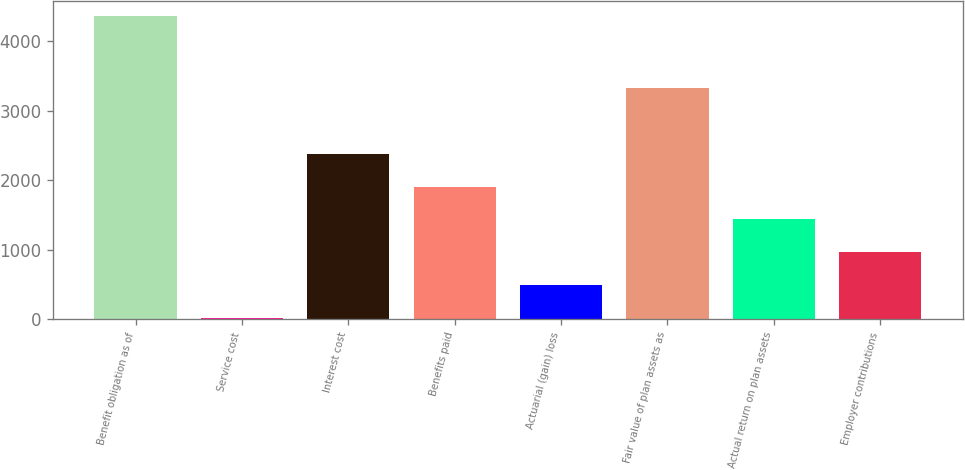<chart> <loc_0><loc_0><loc_500><loc_500><bar_chart><fcel>Benefit obligation as of<fcel>Service cost<fcel>Interest cost<fcel>Benefits paid<fcel>Actuarial (gain) loss<fcel>Fair value of plan assets as<fcel>Actual return on plan assets<fcel>Employer contributions<nl><fcel>4363<fcel>16<fcel>2382.5<fcel>1909.2<fcel>489.3<fcel>3329.1<fcel>1435.9<fcel>962.6<nl></chart> 